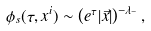<formula> <loc_0><loc_0><loc_500><loc_500>\phi _ { s } ( \tau , x ^ { i } ) \sim \left ( e ^ { \tau } | \vec { x } | \right ) ^ { - \lambda _ { - } } ,</formula> 